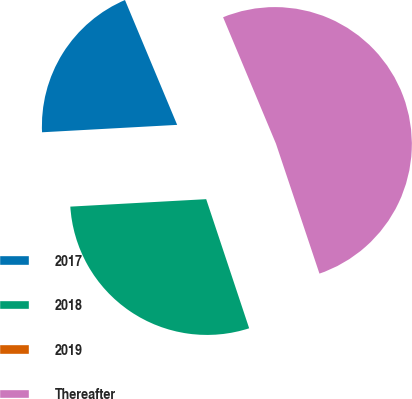Convert chart. <chart><loc_0><loc_0><loc_500><loc_500><pie_chart><fcel>2017<fcel>2018<fcel>2019<fcel>Thereafter<nl><fcel>19.57%<fcel>29.24%<fcel>0.03%<fcel>51.16%<nl></chart> 